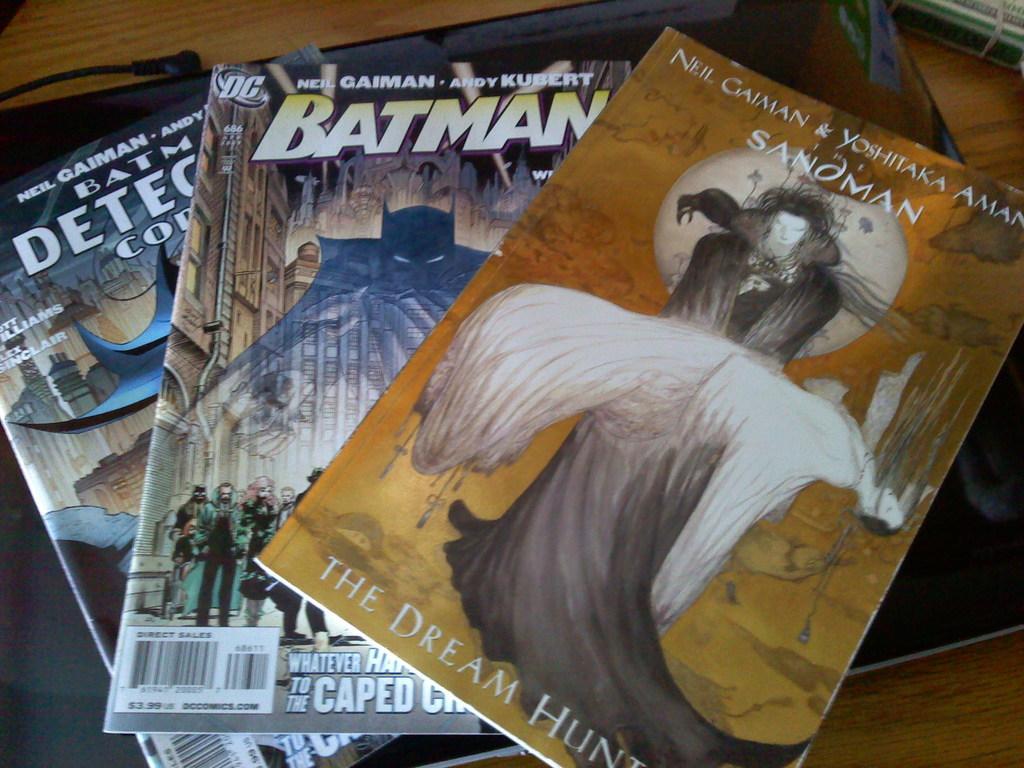Could you give a brief overview of what you see in this image? In this image I can see three books and something is written on it. They are in different color. Books are on the brown color table. 